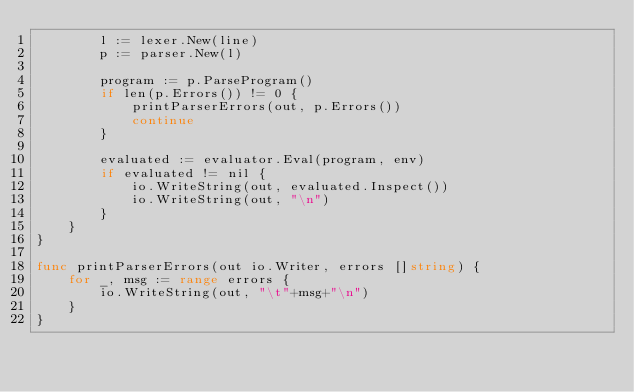Convert code to text. <code><loc_0><loc_0><loc_500><loc_500><_Go_>		l := lexer.New(line)
		p := parser.New(l)

		program := p.ParseProgram()
		if len(p.Errors()) != 0 {
			printParserErrors(out, p.Errors())
			continue
		}

		evaluated := evaluator.Eval(program, env)
		if evaluated != nil {
			io.WriteString(out, evaluated.Inspect())
			io.WriteString(out, "\n")
		}
	}
}

func printParserErrors(out io.Writer, errors []string) {
	for _, msg := range errors {
		io.WriteString(out, "\t"+msg+"\n")
	}
}
</code> 